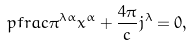Convert formula to latex. <formula><loc_0><loc_0><loc_500><loc_500>\ p f r a c { \pi ^ { \lambda \alpha } } { x ^ { \alpha } } + \frac { 4 \pi } { c } j ^ { \lambda } = 0 ,</formula> 